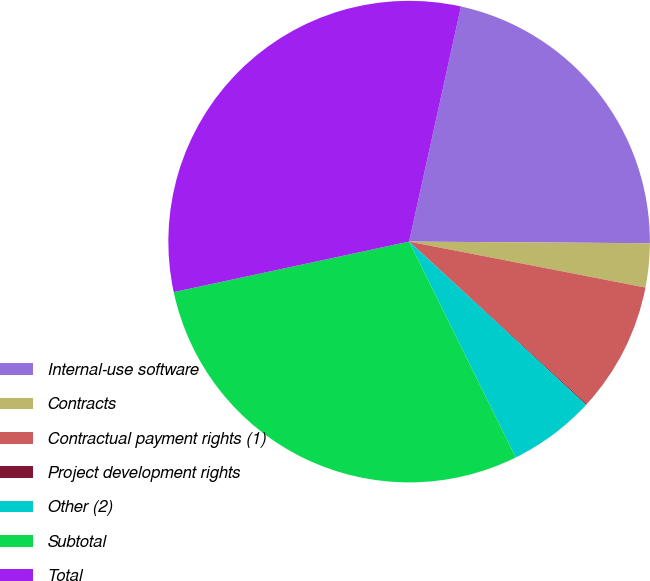Convert chart to OTSL. <chart><loc_0><loc_0><loc_500><loc_500><pie_chart><fcel>Internal-use software<fcel>Contracts<fcel>Contractual payment rights (1)<fcel>Project development rights<fcel>Other (2)<fcel>Subtotal<fcel>Total<nl><fcel>21.65%<fcel>2.95%<fcel>8.73%<fcel>0.07%<fcel>5.84%<fcel>28.94%<fcel>31.82%<nl></chart> 